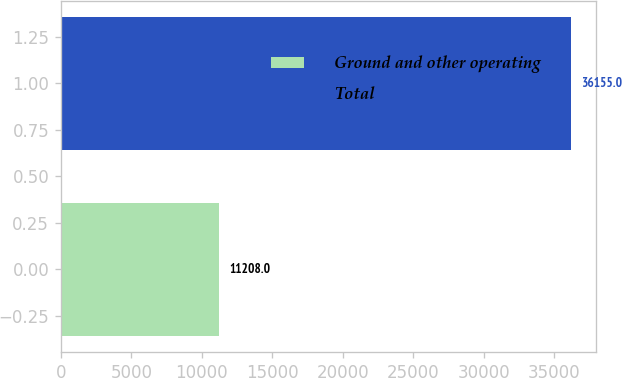<chart> <loc_0><loc_0><loc_500><loc_500><bar_chart><fcel>Ground and other operating<fcel>Total<nl><fcel>11208<fcel>36155<nl></chart> 